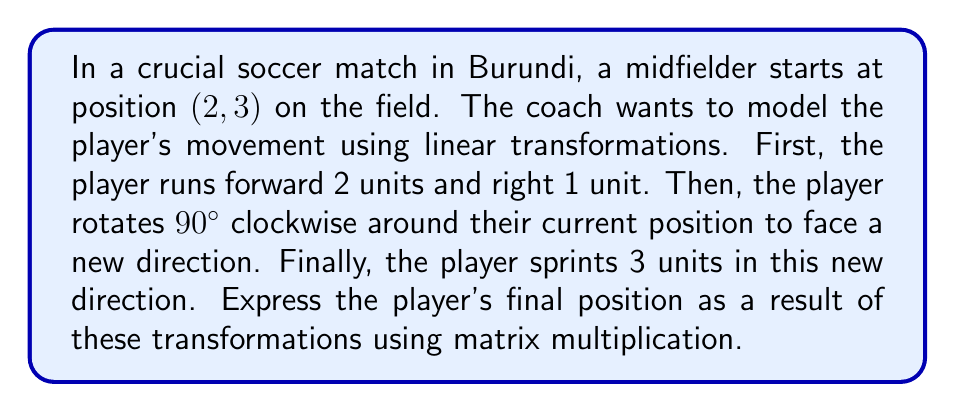Solve this math problem. Let's break this down step-by-step:

1) The initial position is $(2, 3)$. We'll represent this as a column vector:
   $$\vec{v}_0 = \begin{pmatrix} 2 \\ 3 \end{pmatrix}$$

2) The first transformation is a translation of 2 units forward (y-direction) and 1 unit right (x-direction). We can represent this as:
   $$T_1 = \begin{pmatrix} 1 & 0 \\ 0 & 1 \end{pmatrix}\begin{pmatrix} 2 \\ 3 \end{pmatrix} + \begin{pmatrix} 1 \\ 2 \end{pmatrix} = \begin{pmatrix} 3 \\ 5 \end{pmatrix}$$

3) The second transformation is a 90° clockwise rotation. The matrix for this rotation is:
   $$R = \begin{pmatrix} 0 & 1 \\ -1 & 0 \end{pmatrix}$$

4) The final transformation is a movement of 3 units in the new direction. After the 90° clockwise rotation, the player is facing the positive x-direction. So this is equivalent to moving 3 units in the x-direction:
   $$T_2 = \begin{pmatrix} 1 & 0 \\ 0 & 1 \end{pmatrix}\vec{v} + \begin{pmatrix} 3 \\ 0 \end{pmatrix}$$

5) Combining all these transformations:
   $$\vec{v}_f = T_2(R(T_1(\vec{v}_0)))$$
   
   $$= \left(\begin{pmatrix} 1 & 0 \\ 0 & 1 \end{pmatrix}\begin{pmatrix} 0 & 1 \\ -1 & 0 \end{pmatrix}\begin{pmatrix} 3 \\ 5 \end{pmatrix} + \begin{pmatrix} 3 \\ 0 \end{pmatrix}\right)$$
   
   $$= \begin{pmatrix} 1 & 0 \\ 0 & 1 \end{pmatrix}\begin{pmatrix} 5 \\ -3 \end{pmatrix} + \begin{pmatrix} 3 \\ 0 \end{pmatrix} = \begin{pmatrix} 8 \\ -3 \end{pmatrix}$$

Therefore, the player's final position is $(8, -3)$.
Answer: $(8, -3)$ 